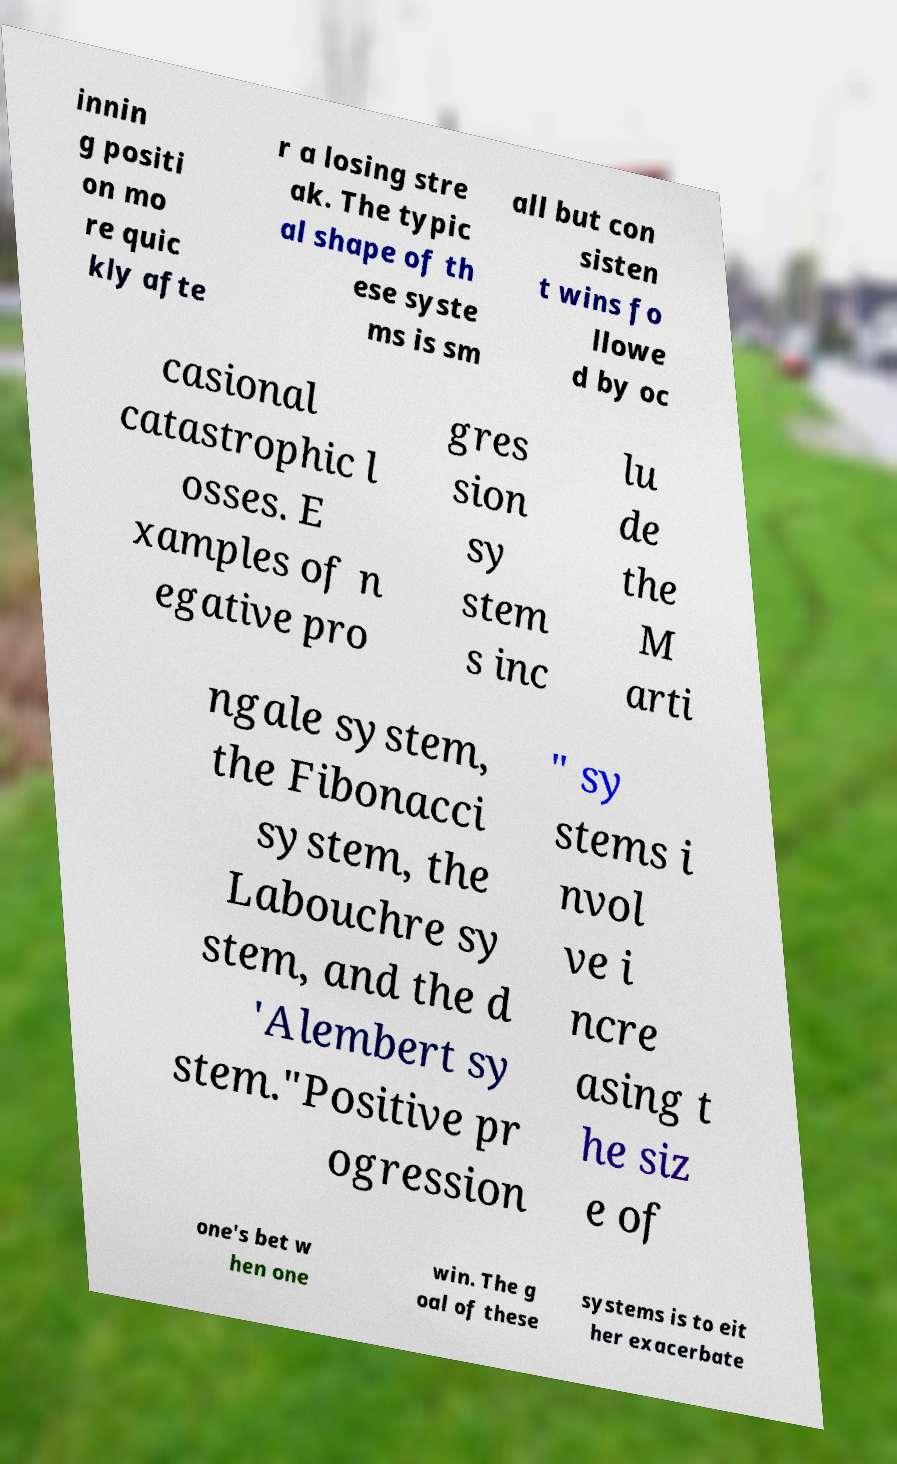There's text embedded in this image that I need extracted. Can you transcribe it verbatim? innin g positi on mo re quic kly afte r a losing stre ak. The typic al shape of th ese syste ms is sm all but con sisten t wins fo llowe d by oc casional catastrophic l osses. E xamples of n egative pro gres sion sy stem s inc lu de the M arti ngale system, the Fibonacci system, the Labouchre sy stem, and the d 'Alembert sy stem."Positive pr ogression " sy stems i nvol ve i ncre asing t he siz e of one's bet w hen one win. The g oal of these systems is to eit her exacerbate 